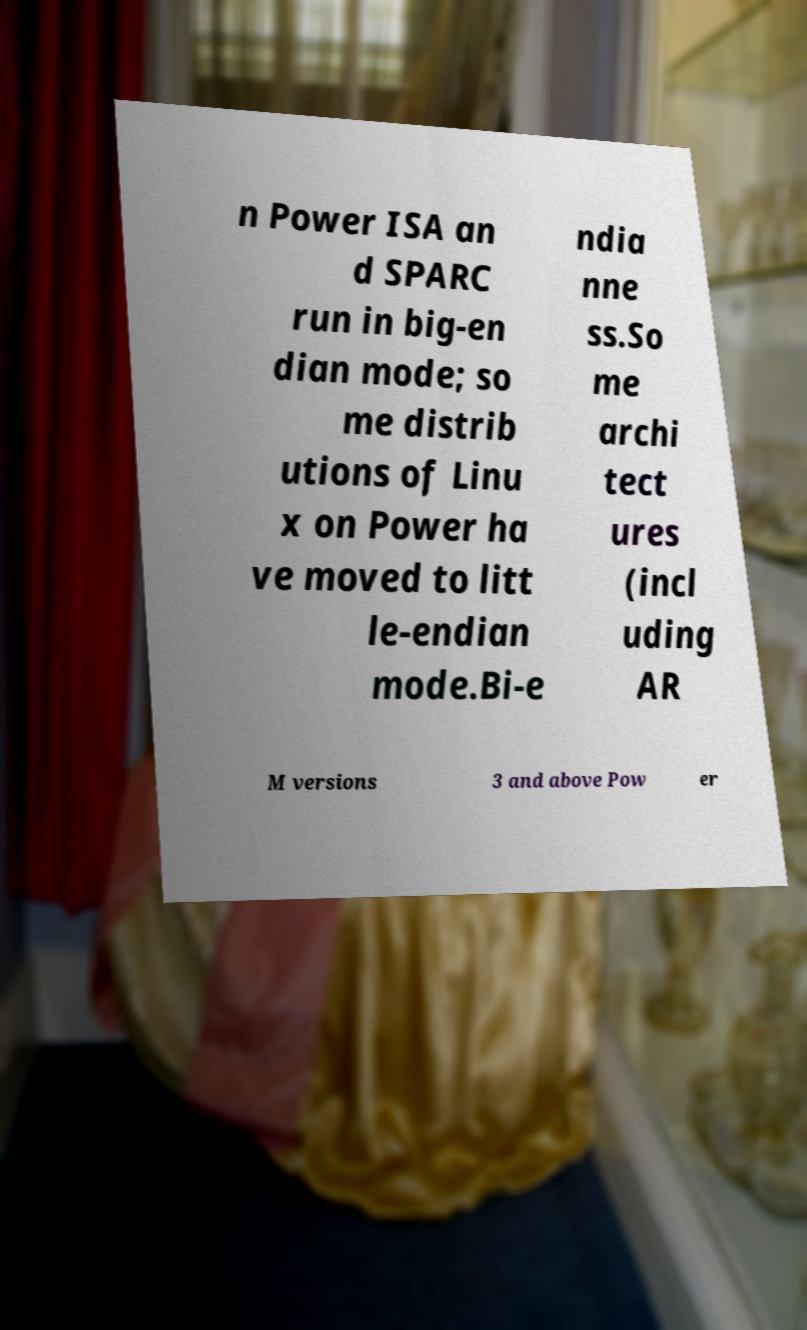Please identify and transcribe the text found in this image. n Power ISA an d SPARC run in big-en dian mode; so me distrib utions of Linu x on Power ha ve moved to litt le-endian mode.Bi-e ndia nne ss.So me archi tect ures (incl uding AR M versions 3 and above Pow er 